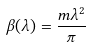<formula> <loc_0><loc_0><loc_500><loc_500>\beta ( \lambda ) = \frac { m \lambda ^ { 2 } } { \pi }</formula> 